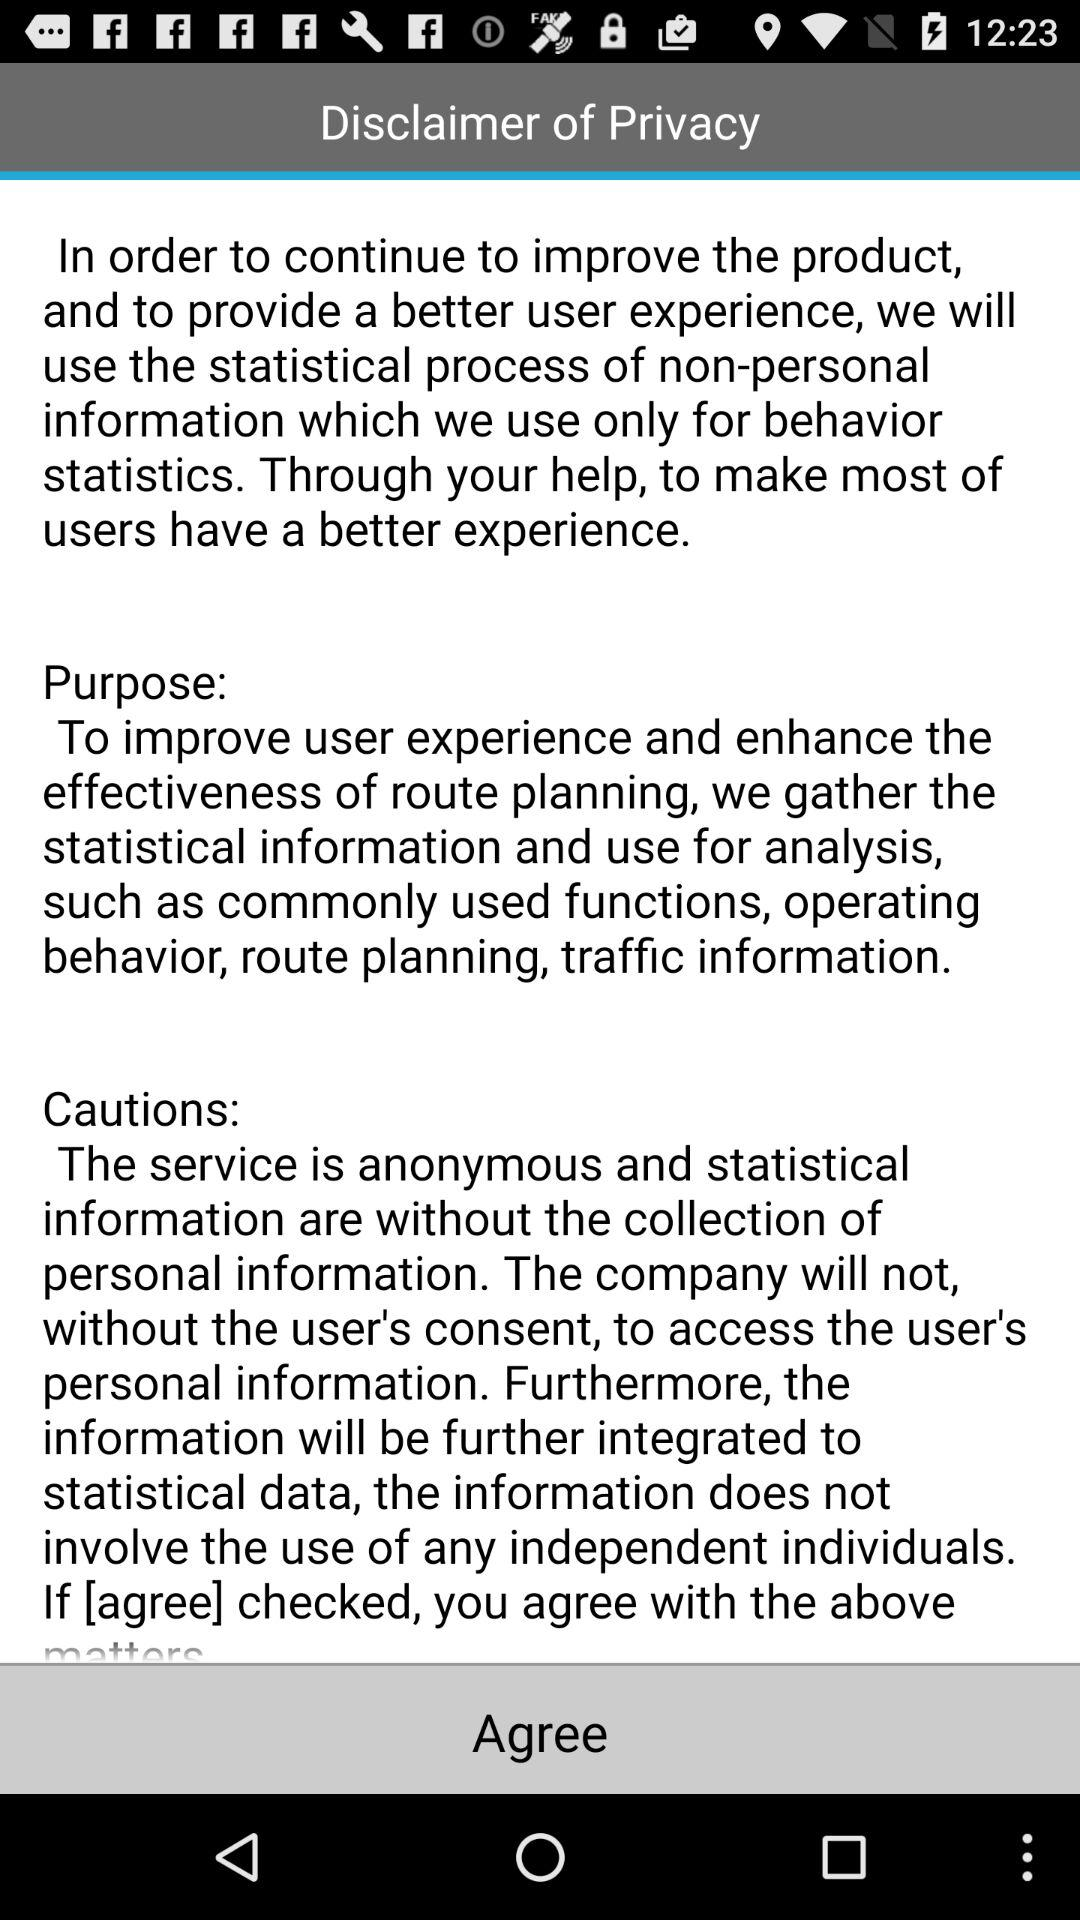How many sentences are there in the disclaimer of privacy?
Answer the question using a single word or phrase. 3 